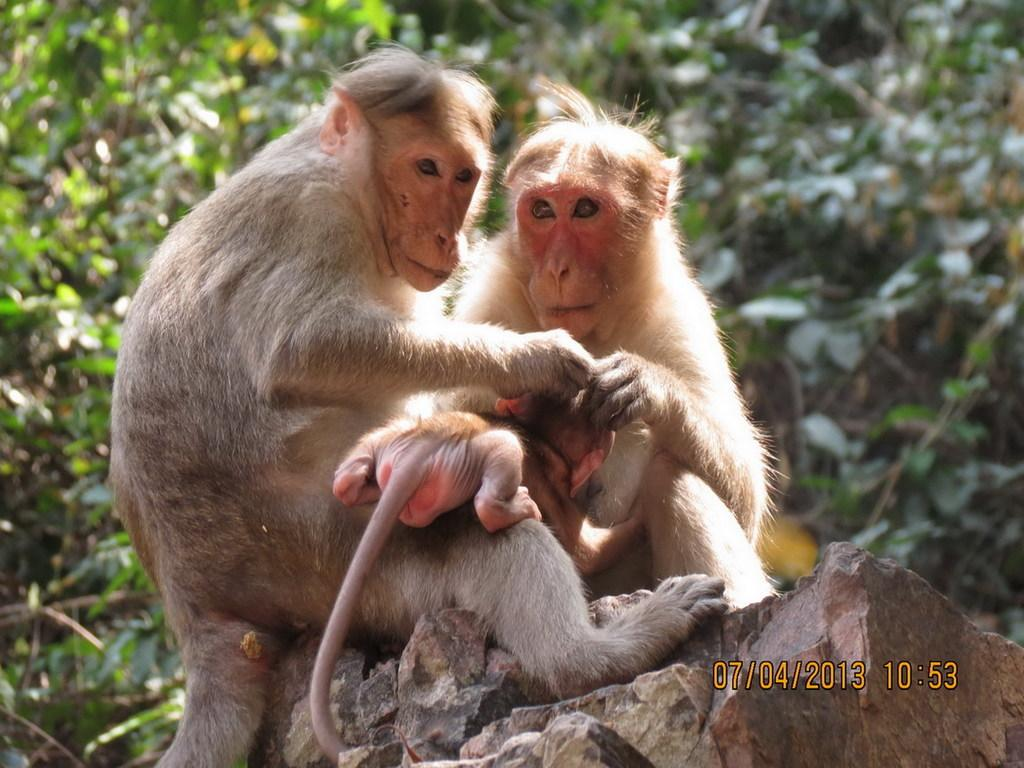What is the main subject of the image? The main subject of the image is animals sitting on the rocks. What can be seen in the background of the image? There are trees in the background of the image. Are there any additional elements on the image? Yes, there are numbers written on the image on the right side. What type of eye can be seen on the animals in the image? There are no eyes visible on the animals in the image; only their bodies and the rocks they are sitting on can be seen. 